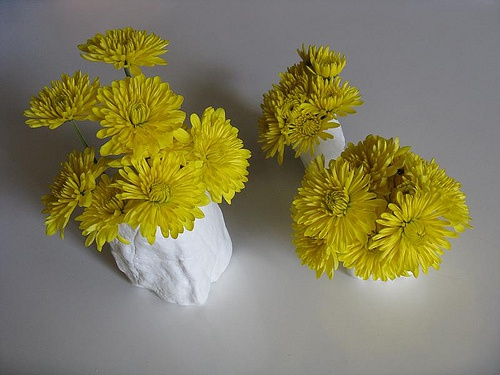Describe the objects in this image and their specific colors. I can see potted plant in gray, olive, and lightgray tones, potted plant in gray and olive tones, vase in gray, lightgray, and darkgray tones, and vase in gray, darkgray, and olive tones in this image. 